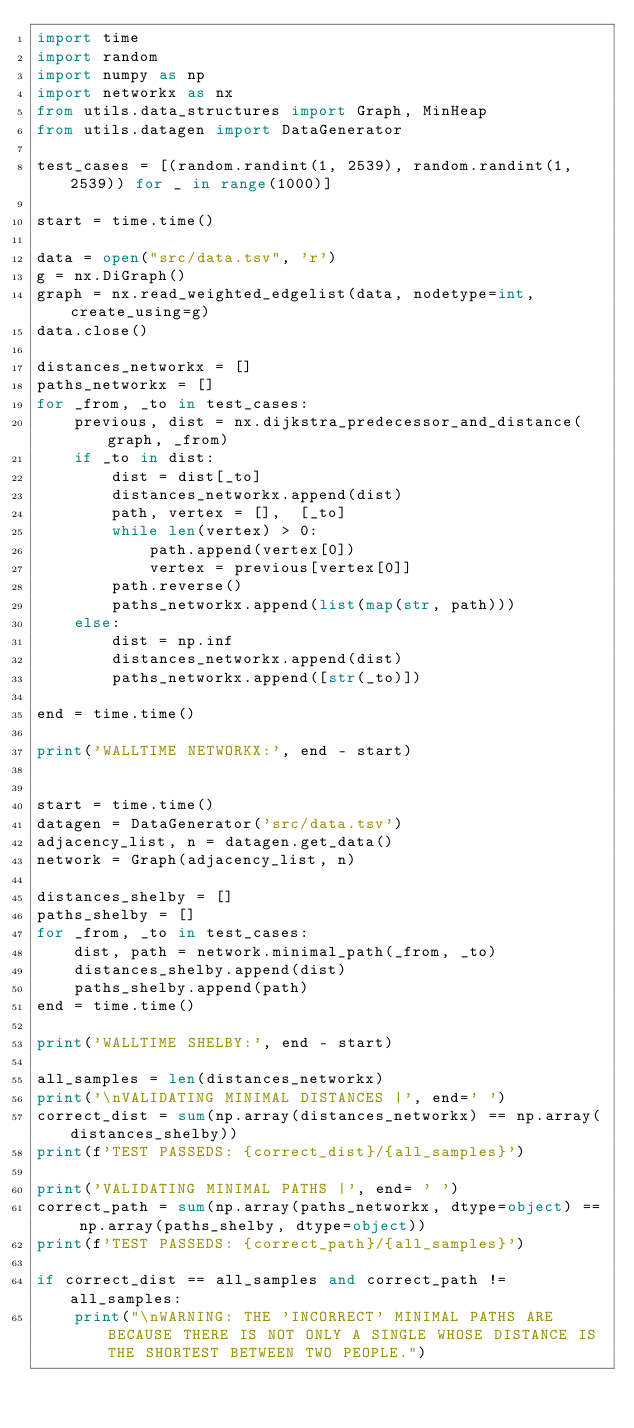<code> <loc_0><loc_0><loc_500><loc_500><_Python_>import time
import random
import numpy as np
import networkx as nx
from utils.data_structures import Graph, MinHeap
from utils.datagen import DataGenerator

test_cases = [(random.randint(1, 2539), random.randint(1, 2539)) for _ in range(1000)]

start = time.time()

data = open("src/data.tsv", 'r')
g = nx.DiGraph()
graph = nx.read_weighted_edgelist(data, nodetype=int, create_using=g)
data.close()

distances_networkx = []
paths_networkx = []
for _from, _to in test_cases:
    previous, dist = nx.dijkstra_predecessor_and_distance(graph, _from)
    if _to in dist:
        dist = dist[_to]
        distances_networkx.append(dist)
        path, vertex = [],  [_to]
        while len(vertex) > 0:
            path.append(vertex[0])
            vertex = previous[vertex[0]]
        path.reverse()
        paths_networkx.append(list(map(str, path)))
    else:
        dist = np.inf
        distances_networkx.append(dist)
        paths_networkx.append([str(_to)])

end = time.time()

print('WALLTIME NETWORKX:', end - start)


start = time.time()
datagen = DataGenerator('src/data.tsv')
adjacency_list, n = datagen.get_data()
network = Graph(adjacency_list, n)

distances_shelby = []
paths_shelby = []
for _from, _to in test_cases:
    dist, path = network.minimal_path(_from, _to)
    distances_shelby.append(dist)
    paths_shelby.append(path)
end = time.time()

print('WALLTIME SHELBY:', end - start)

all_samples = len(distances_networkx)
print('\nVALIDATING MINIMAL DISTANCES |', end=' ')
correct_dist = sum(np.array(distances_networkx) == np.array(distances_shelby))
print(f'TEST PASSEDS: {correct_dist}/{all_samples}')

print('VALIDATING MINIMAL PATHS |', end= ' ')
correct_path = sum(np.array(paths_networkx, dtype=object) == np.array(paths_shelby, dtype=object))
print(f'TEST PASSEDS: {correct_path}/{all_samples}')

if correct_dist == all_samples and correct_path != all_samples:
    print("\nWARNING: THE 'INCORRECT' MINIMAL PATHS ARE BECAUSE THERE IS NOT ONLY A SINGLE WHOSE DISTANCE IS THE SHORTEST BETWEEN TWO PEOPLE.")
    </code> 